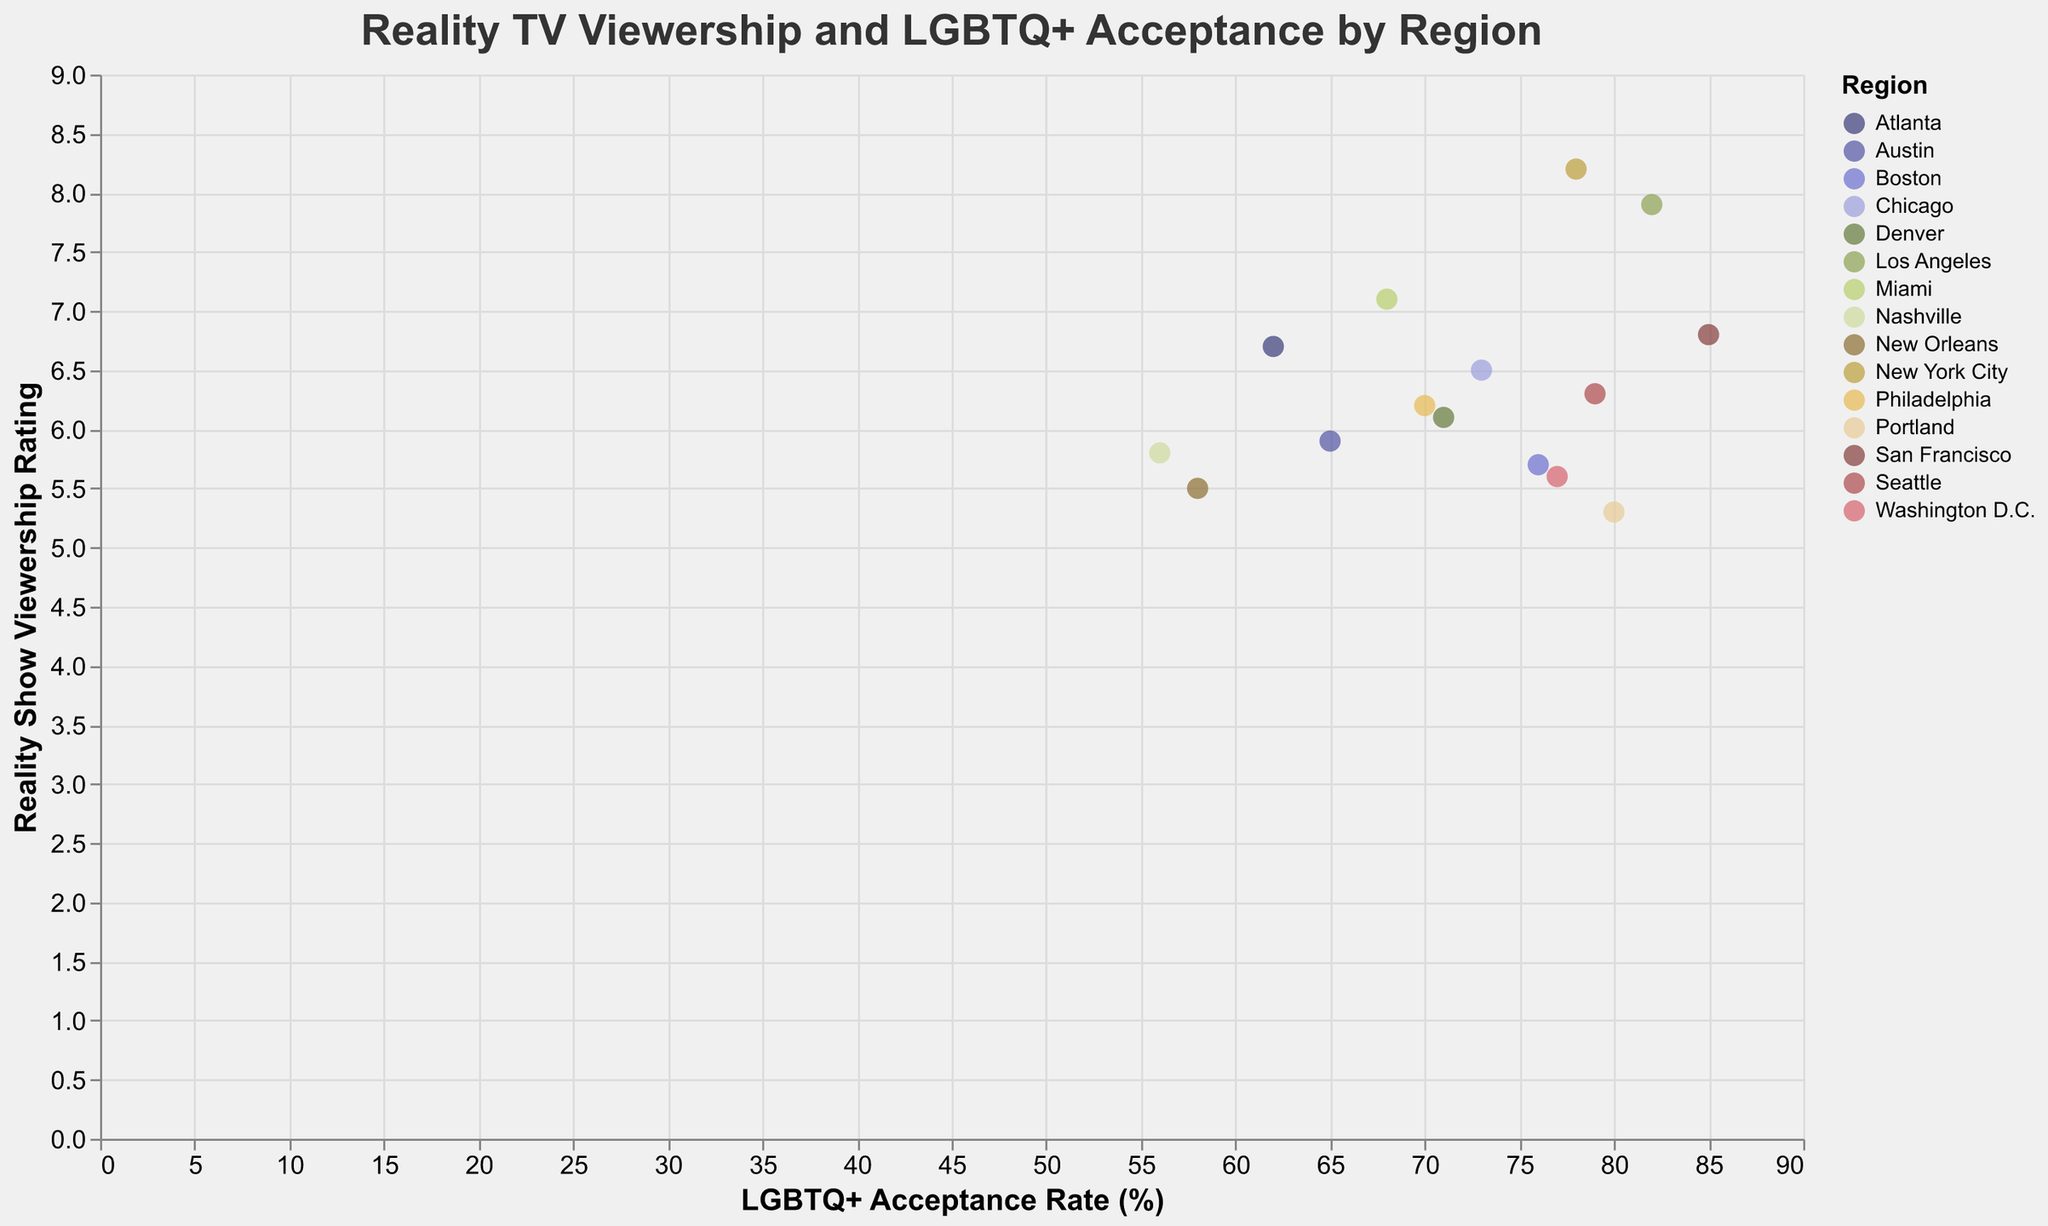What is the title of the figure? The title is displayed at the top of the figure. It reads "Reality TV Viewership and LGBTQ+ Acceptance by Region."
Answer: Reality TV Viewership and LGBTQ+ Acceptance by Region Which region has the highest LGBTQ+ acceptance rate? Look for the highest value on the x-axis, which represents the LGBTQ+ Acceptance Rate, and identify the region associated with that data point.
Answer: San Francisco How many regions have an LGBTQ+ acceptance rate of 70% or higher? Identify data points with an x-axis value of 70% or more and count the number of such regions.
Answer: 9 Which reality show has the highest viewership rating, and in which region is it popular? Look for the highest value on the y-axis, which represents the Viewership Rating, and check the tooltip or color legend for the corresponding show and region.
Answer: RuPaul's Drag Race in New York City Is there a positive correlation between LGBTQ+ acceptance rate and viewership rating of reality TV shows? Examine the trend of data points. If points generally increase along both the x and y axes, there is a positive correlation.
Answer: Yes Which region has the lowest viewership rating, and what is its LGBTQ+ acceptance rate? Locate the data point with the lowest y-axis value and check the x-axis value and tooltip for its LGBTQ+ acceptance rate and region.
Answer: New Orleans with a 58% acceptance rate Which region has the highest viewership rating but an LGBTQ+ acceptance rate below 70%? Look for the data point with the highest y-value among those with x-values below 70% and verify the region.
Answer: Miami Compare the viewership ratings of regions with LGBTQ+ acceptance rates of 80% and above versus those below 80%. Which group has a higher average rating? Calculate the average viewership rating for regions with acceptance rates 80% and above and compare it with the average rating for regions below 80%.
Answer: Greater for 80% and above Do any regions have lower viewership ratings despite having high LGBTQ+ acceptance rates? Filter data points with high x-values (LGBTQ+ acceptance rates) and check if any have lower y-values (viewership ratings).
Answer: Yes, Portland 